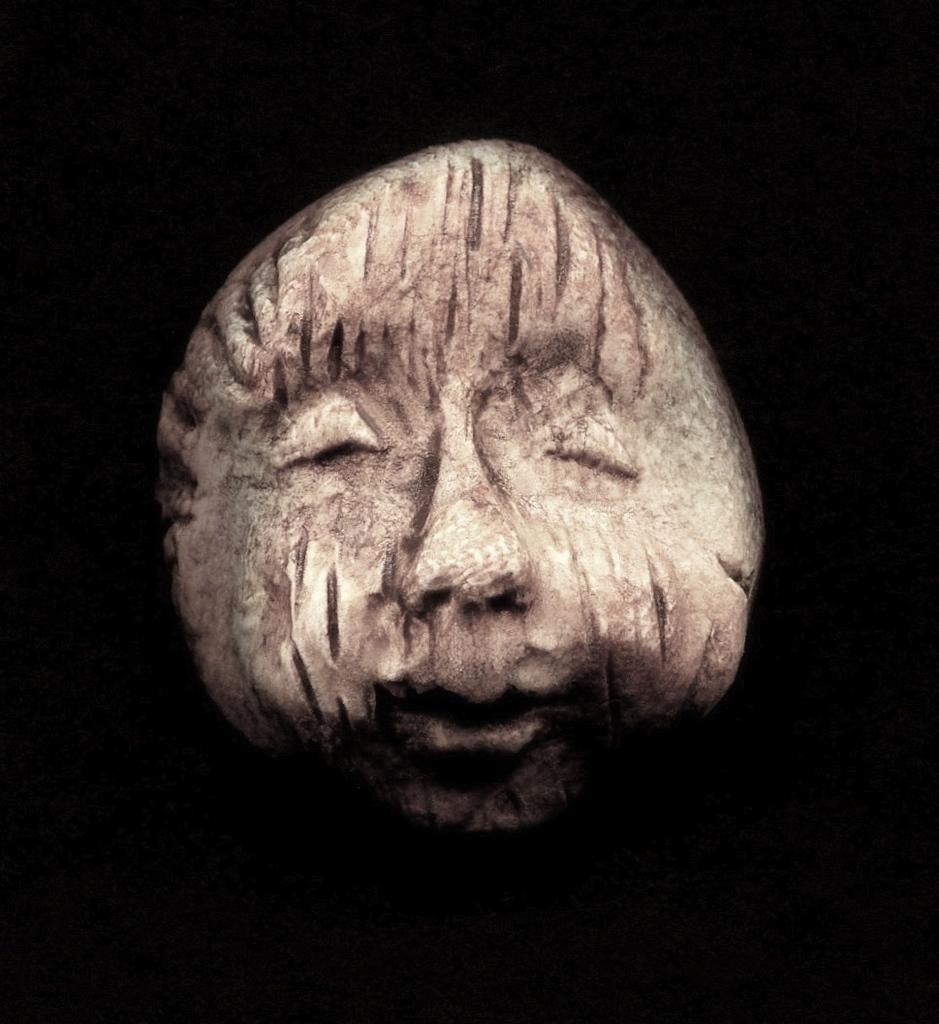What is the main subject of the image? The main subject of the image is a rock. Are there any additional features on the rock? Yes, there are carvings on the rock. How does the rock provide support for the nerve in the image? The image does not show any nerves or any indication of the rock providing support for a nerve. 